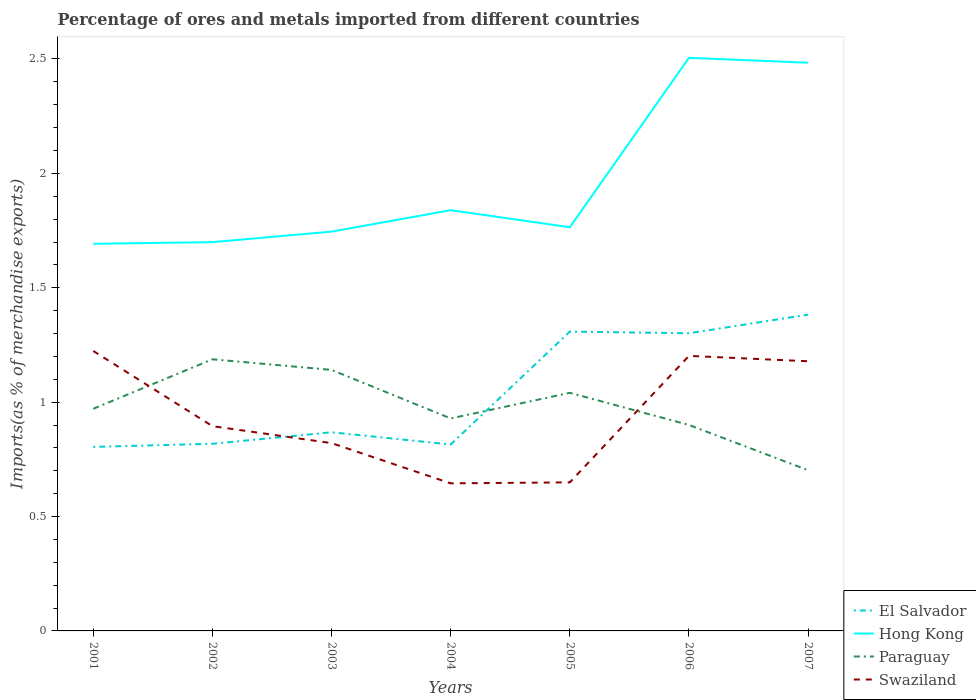How many different coloured lines are there?
Keep it short and to the point. 4. Does the line corresponding to Swaziland intersect with the line corresponding to Paraguay?
Keep it short and to the point. Yes. Across all years, what is the maximum percentage of imports to different countries in Swaziland?
Your answer should be compact. 0.65. In which year was the percentage of imports to different countries in Paraguay maximum?
Give a very brief answer. 2007. What is the total percentage of imports to different countries in Swaziland in the graph?
Provide a short and direct response. -0.53. What is the difference between the highest and the second highest percentage of imports to different countries in Swaziland?
Your response must be concise. 0.58. What is the difference between the highest and the lowest percentage of imports to different countries in Hong Kong?
Offer a very short reply. 2. How many lines are there?
Offer a very short reply. 4. Are the values on the major ticks of Y-axis written in scientific E-notation?
Your answer should be very brief. No. Does the graph contain any zero values?
Keep it short and to the point. No. Does the graph contain grids?
Your answer should be compact. No. Where does the legend appear in the graph?
Provide a short and direct response. Bottom right. What is the title of the graph?
Provide a succinct answer. Percentage of ores and metals imported from different countries. What is the label or title of the Y-axis?
Your response must be concise. Imports(as % of merchandise exports). What is the Imports(as % of merchandise exports) in El Salvador in 2001?
Offer a terse response. 0.8. What is the Imports(as % of merchandise exports) of Hong Kong in 2001?
Make the answer very short. 1.69. What is the Imports(as % of merchandise exports) of Paraguay in 2001?
Provide a succinct answer. 0.97. What is the Imports(as % of merchandise exports) in Swaziland in 2001?
Your answer should be compact. 1.22. What is the Imports(as % of merchandise exports) in El Salvador in 2002?
Give a very brief answer. 0.82. What is the Imports(as % of merchandise exports) of Hong Kong in 2002?
Give a very brief answer. 1.7. What is the Imports(as % of merchandise exports) in Paraguay in 2002?
Provide a succinct answer. 1.19. What is the Imports(as % of merchandise exports) of Swaziland in 2002?
Offer a very short reply. 0.9. What is the Imports(as % of merchandise exports) of El Salvador in 2003?
Ensure brevity in your answer.  0.87. What is the Imports(as % of merchandise exports) in Hong Kong in 2003?
Offer a very short reply. 1.75. What is the Imports(as % of merchandise exports) of Paraguay in 2003?
Ensure brevity in your answer.  1.14. What is the Imports(as % of merchandise exports) in Swaziland in 2003?
Offer a very short reply. 0.82. What is the Imports(as % of merchandise exports) in El Salvador in 2004?
Keep it short and to the point. 0.81. What is the Imports(as % of merchandise exports) in Hong Kong in 2004?
Your answer should be compact. 1.84. What is the Imports(as % of merchandise exports) of Paraguay in 2004?
Provide a succinct answer. 0.93. What is the Imports(as % of merchandise exports) of Swaziland in 2004?
Keep it short and to the point. 0.65. What is the Imports(as % of merchandise exports) of El Salvador in 2005?
Make the answer very short. 1.31. What is the Imports(as % of merchandise exports) of Hong Kong in 2005?
Offer a very short reply. 1.76. What is the Imports(as % of merchandise exports) of Paraguay in 2005?
Your answer should be very brief. 1.04. What is the Imports(as % of merchandise exports) of Swaziland in 2005?
Your answer should be very brief. 0.65. What is the Imports(as % of merchandise exports) in El Salvador in 2006?
Give a very brief answer. 1.3. What is the Imports(as % of merchandise exports) in Hong Kong in 2006?
Offer a very short reply. 2.5. What is the Imports(as % of merchandise exports) of Paraguay in 2006?
Keep it short and to the point. 0.9. What is the Imports(as % of merchandise exports) in Swaziland in 2006?
Give a very brief answer. 1.2. What is the Imports(as % of merchandise exports) in El Salvador in 2007?
Offer a terse response. 1.38. What is the Imports(as % of merchandise exports) in Hong Kong in 2007?
Make the answer very short. 2.48. What is the Imports(as % of merchandise exports) of Paraguay in 2007?
Give a very brief answer. 0.7. What is the Imports(as % of merchandise exports) in Swaziland in 2007?
Your response must be concise. 1.18. Across all years, what is the maximum Imports(as % of merchandise exports) in El Salvador?
Make the answer very short. 1.38. Across all years, what is the maximum Imports(as % of merchandise exports) of Hong Kong?
Make the answer very short. 2.5. Across all years, what is the maximum Imports(as % of merchandise exports) in Paraguay?
Offer a terse response. 1.19. Across all years, what is the maximum Imports(as % of merchandise exports) of Swaziland?
Keep it short and to the point. 1.22. Across all years, what is the minimum Imports(as % of merchandise exports) in El Salvador?
Offer a very short reply. 0.8. Across all years, what is the minimum Imports(as % of merchandise exports) in Hong Kong?
Your response must be concise. 1.69. Across all years, what is the minimum Imports(as % of merchandise exports) in Paraguay?
Make the answer very short. 0.7. Across all years, what is the minimum Imports(as % of merchandise exports) of Swaziland?
Offer a terse response. 0.65. What is the total Imports(as % of merchandise exports) of El Salvador in the graph?
Provide a succinct answer. 7.3. What is the total Imports(as % of merchandise exports) of Hong Kong in the graph?
Your answer should be compact. 13.73. What is the total Imports(as % of merchandise exports) in Paraguay in the graph?
Your response must be concise. 6.87. What is the total Imports(as % of merchandise exports) of Swaziland in the graph?
Your answer should be very brief. 6.62. What is the difference between the Imports(as % of merchandise exports) in El Salvador in 2001 and that in 2002?
Provide a succinct answer. -0.01. What is the difference between the Imports(as % of merchandise exports) in Hong Kong in 2001 and that in 2002?
Your answer should be compact. -0.01. What is the difference between the Imports(as % of merchandise exports) of Paraguay in 2001 and that in 2002?
Offer a very short reply. -0.22. What is the difference between the Imports(as % of merchandise exports) in Swaziland in 2001 and that in 2002?
Your response must be concise. 0.33. What is the difference between the Imports(as % of merchandise exports) of El Salvador in 2001 and that in 2003?
Give a very brief answer. -0.06. What is the difference between the Imports(as % of merchandise exports) in Hong Kong in 2001 and that in 2003?
Offer a very short reply. -0.05. What is the difference between the Imports(as % of merchandise exports) in Paraguay in 2001 and that in 2003?
Your answer should be compact. -0.17. What is the difference between the Imports(as % of merchandise exports) in Swaziland in 2001 and that in 2003?
Your answer should be compact. 0.4. What is the difference between the Imports(as % of merchandise exports) of El Salvador in 2001 and that in 2004?
Make the answer very short. -0.01. What is the difference between the Imports(as % of merchandise exports) of Hong Kong in 2001 and that in 2004?
Offer a terse response. -0.15. What is the difference between the Imports(as % of merchandise exports) of Paraguay in 2001 and that in 2004?
Your response must be concise. 0.04. What is the difference between the Imports(as % of merchandise exports) of Swaziland in 2001 and that in 2004?
Offer a very short reply. 0.58. What is the difference between the Imports(as % of merchandise exports) in El Salvador in 2001 and that in 2005?
Ensure brevity in your answer.  -0.5. What is the difference between the Imports(as % of merchandise exports) in Hong Kong in 2001 and that in 2005?
Ensure brevity in your answer.  -0.07. What is the difference between the Imports(as % of merchandise exports) of Paraguay in 2001 and that in 2005?
Your answer should be compact. -0.07. What is the difference between the Imports(as % of merchandise exports) in Swaziland in 2001 and that in 2005?
Your response must be concise. 0.57. What is the difference between the Imports(as % of merchandise exports) in El Salvador in 2001 and that in 2006?
Your answer should be very brief. -0.5. What is the difference between the Imports(as % of merchandise exports) of Hong Kong in 2001 and that in 2006?
Give a very brief answer. -0.81. What is the difference between the Imports(as % of merchandise exports) of Paraguay in 2001 and that in 2006?
Your answer should be very brief. 0.07. What is the difference between the Imports(as % of merchandise exports) of Swaziland in 2001 and that in 2006?
Offer a terse response. 0.02. What is the difference between the Imports(as % of merchandise exports) of El Salvador in 2001 and that in 2007?
Make the answer very short. -0.58. What is the difference between the Imports(as % of merchandise exports) in Hong Kong in 2001 and that in 2007?
Your answer should be compact. -0.79. What is the difference between the Imports(as % of merchandise exports) in Paraguay in 2001 and that in 2007?
Your response must be concise. 0.27. What is the difference between the Imports(as % of merchandise exports) in Swaziland in 2001 and that in 2007?
Give a very brief answer. 0.04. What is the difference between the Imports(as % of merchandise exports) of El Salvador in 2002 and that in 2003?
Make the answer very short. -0.05. What is the difference between the Imports(as % of merchandise exports) in Hong Kong in 2002 and that in 2003?
Offer a very short reply. -0.05. What is the difference between the Imports(as % of merchandise exports) of Paraguay in 2002 and that in 2003?
Your response must be concise. 0.05. What is the difference between the Imports(as % of merchandise exports) of Swaziland in 2002 and that in 2003?
Make the answer very short. 0.07. What is the difference between the Imports(as % of merchandise exports) of El Salvador in 2002 and that in 2004?
Ensure brevity in your answer.  0. What is the difference between the Imports(as % of merchandise exports) of Hong Kong in 2002 and that in 2004?
Make the answer very short. -0.14. What is the difference between the Imports(as % of merchandise exports) in Paraguay in 2002 and that in 2004?
Make the answer very short. 0.26. What is the difference between the Imports(as % of merchandise exports) of El Salvador in 2002 and that in 2005?
Keep it short and to the point. -0.49. What is the difference between the Imports(as % of merchandise exports) in Hong Kong in 2002 and that in 2005?
Offer a very short reply. -0.07. What is the difference between the Imports(as % of merchandise exports) in Paraguay in 2002 and that in 2005?
Your answer should be very brief. 0.15. What is the difference between the Imports(as % of merchandise exports) of Swaziland in 2002 and that in 2005?
Provide a short and direct response. 0.25. What is the difference between the Imports(as % of merchandise exports) in El Salvador in 2002 and that in 2006?
Offer a terse response. -0.48. What is the difference between the Imports(as % of merchandise exports) of Hong Kong in 2002 and that in 2006?
Give a very brief answer. -0.81. What is the difference between the Imports(as % of merchandise exports) of Paraguay in 2002 and that in 2006?
Keep it short and to the point. 0.29. What is the difference between the Imports(as % of merchandise exports) of Swaziland in 2002 and that in 2006?
Offer a very short reply. -0.31. What is the difference between the Imports(as % of merchandise exports) of El Salvador in 2002 and that in 2007?
Offer a terse response. -0.56. What is the difference between the Imports(as % of merchandise exports) of Hong Kong in 2002 and that in 2007?
Offer a very short reply. -0.78. What is the difference between the Imports(as % of merchandise exports) in Paraguay in 2002 and that in 2007?
Your answer should be compact. 0.48. What is the difference between the Imports(as % of merchandise exports) of Swaziland in 2002 and that in 2007?
Offer a very short reply. -0.28. What is the difference between the Imports(as % of merchandise exports) in El Salvador in 2003 and that in 2004?
Provide a succinct answer. 0.05. What is the difference between the Imports(as % of merchandise exports) in Hong Kong in 2003 and that in 2004?
Keep it short and to the point. -0.09. What is the difference between the Imports(as % of merchandise exports) in Paraguay in 2003 and that in 2004?
Give a very brief answer. 0.21. What is the difference between the Imports(as % of merchandise exports) in Swaziland in 2003 and that in 2004?
Keep it short and to the point. 0.18. What is the difference between the Imports(as % of merchandise exports) in El Salvador in 2003 and that in 2005?
Make the answer very short. -0.44. What is the difference between the Imports(as % of merchandise exports) in Hong Kong in 2003 and that in 2005?
Offer a terse response. -0.02. What is the difference between the Imports(as % of merchandise exports) in Paraguay in 2003 and that in 2005?
Offer a terse response. 0.1. What is the difference between the Imports(as % of merchandise exports) of Swaziland in 2003 and that in 2005?
Provide a succinct answer. 0.17. What is the difference between the Imports(as % of merchandise exports) of El Salvador in 2003 and that in 2006?
Offer a terse response. -0.43. What is the difference between the Imports(as % of merchandise exports) in Hong Kong in 2003 and that in 2006?
Give a very brief answer. -0.76. What is the difference between the Imports(as % of merchandise exports) in Paraguay in 2003 and that in 2006?
Your answer should be compact. 0.24. What is the difference between the Imports(as % of merchandise exports) in Swaziland in 2003 and that in 2006?
Ensure brevity in your answer.  -0.38. What is the difference between the Imports(as % of merchandise exports) of El Salvador in 2003 and that in 2007?
Ensure brevity in your answer.  -0.51. What is the difference between the Imports(as % of merchandise exports) in Hong Kong in 2003 and that in 2007?
Your answer should be very brief. -0.74. What is the difference between the Imports(as % of merchandise exports) of Paraguay in 2003 and that in 2007?
Your response must be concise. 0.44. What is the difference between the Imports(as % of merchandise exports) of Swaziland in 2003 and that in 2007?
Give a very brief answer. -0.36. What is the difference between the Imports(as % of merchandise exports) in El Salvador in 2004 and that in 2005?
Ensure brevity in your answer.  -0.49. What is the difference between the Imports(as % of merchandise exports) of Hong Kong in 2004 and that in 2005?
Make the answer very short. 0.07. What is the difference between the Imports(as % of merchandise exports) in Paraguay in 2004 and that in 2005?
Give a very brief answer. -0.11. What is the difference between the Imports(as % of merchandise exports) of Swaziland in 2004 and that in 2005?
Your answer should be very brief. -0. What is the difference between the Imports(as % of merchandise exports) of El Salvador in 2004 and that in 2006?
Provide a short and direct response. -0.49. What is the difference between the Imports(as % of merchandise exports) in Hong Kong in 2004 and that in 2006?
Provide a succinct answer. -0.67. What is the difference between the Imports(as % of merchandise exports) in Paraguay in 2004 and that in 2006?
Offer a terse response. 0.03. What is the difference between the Imports(as % of merchandise exports) in Swaziland in 2004 and that in 2006?
Your answer should be very brief. -0.56. What is the difference between the Imports(as % of merchandise exports) in El Salvador in 2004 and that in 2007?
Ensure brevity in your answer.  -0.57. What is the difference between the Imports(as % of merchandise exports) of Hong Kong in 2004 and that in 2007?
Offer a terse response. -0.64. What is the difference between the Imports(as % of merchandise exports) of Paraguay in 2004 and that in 2007?
Your answer should be compact. 0.23. What is the difference between the Imports(as % of merchandise exports) of Swaziland in 2004 and that in 2007?
Give a very brief answer. -0.53. What is the difference between the Imports(as % of merchandise exports) in El Salvador in 2005 and that in 2006?
Keep it short and to the point. 0.01. What is the difference between the Imports(as % of merchandise exports) of Hong Kong in 2005 and that in 2006?
Your answer should be very brief. -0.74. What is the difference between the Imports(as % of merchandise exports) of Paraguay in 2005 and that in 2006?
Offer a terse response. 0.14. What is the difference between the Imports(as % of merchandise exports) of Swaziland in 2005 and that in 2006?
Offer a very short reply. -0.55. What is the difference between the Imports(as % of merchandise exports) in El Salvador in 2005 and that in 2007?
Provide a succinct answer. -0.07. What is the difference between the Imports(as % of merchandise exports) in Hong Kong in 2005 and that in 2007?
Make the answer very short. -0.72. What is the difference between the Imports(as % of merchandise exports) of Paraguay in 2005 and that in 2007?
Your response must be concise. 0.34. What is the difference between the Imports(as % of merchandise exports) of Swaziland in 2005 and that in 2007?
Provide a succinct answer. -0.53. What is the difference between the Imports(as % of merchandise exports) in El Salvador in 2006 and that in 2007?
Make the answer very short. -0.08. What is the difference between the Imports(as % of merchandise exports) in Hong Kong in 2006 and that in 2007?
Offer a terse response. 0.02. What is the difference between the Imports(as % of merchandise exports) of Paraguay in 2006 and that in 2007?
Offer a very short reply. 0.2. What is the difference between the Imports(as % of merchandise exports) of Swaziland in 2006 and that in 2007?
Provide a short and direct response. 0.02. What is the difference between the Imports(as % of merchandise exports) of El Salvador in 2001 and the Imports(as % of merchandise exports) of Hong Kong in 2002?
Offer a very short reply. -0.9. What is the difference between the Imports(as % of merchandise exports) of El Salvador in 2001 and the Imports(as % of merchandise exports) of Paraguay in 2002?
Provide a succinct answer. -0.38. What is the difference between the Imports(as % of merchandise exports) in El Salvador in 2001 and the Imports(as % of merchandise exports) in Swaziland in 2002?
Your response must be concise. -0.09. What is the difference between the Imports(as % of merchandise exports) of Hong Kong in 2001 and the Imports(as % of merchandise exports) of Paraguay in 2002?
Offer a terse response. 0.5. What is the difference between the Imports(as % of merchandise exports) in Hong Kong in 2001 and the Imports(as % of merchandise exports) in Swaziland in 2002?
Ensure brevity in your answer.  0.8. What is the difference between the Imports(as % of merchandise exports) in Paraguay in 2001 and the Imports(as % of merchandise exports) in Swaziland in 2002?
Your answer should be very brief. 0.08. What is the difference between the Imports(as % of merchandise exports) of El Salvador in 2001 and the Imports(as % of merchandise exports) of Hong Kong in 2003?
Make the answer very short. -0.94. What is the difference between the Imports(as % of merchandise exports) in El Salvador in 2001 and the Imports(as % of merchandise exports) in Paraguay in 2003?
Provide a short and direct response. -0.34. What is the difference between the Imports(as % of merchandise exports) of El Salvador in 2001 and the Imports(as % of merchandise exports) of Swaziland in 2003?
Offer a very short reply. -0.02. What is the difference between the Imports(as % of merchandise exports) in Hong Kong in 2001 and the Imports(as % of merchandise exports) in Paraguay in 2003?
Keep it short and to the point. 0.55. What is the difference between the Imports(as % of merchandise exports) of Hong Kong in 2001 and the Imports(as % of merchandise exports) of Swaziland in 2003?
Offer a very short reply. 0.87. What is the difference between the Imports(as % of merchandise exports) of Paraguay in 2001 and the Imports(as % of merchandise exports) of Swaziland in 2003?
Make the answer very short. 0.15. What is the difference between the Imports(as % of merchandise exports) of El Salvador in 2001 and the Imports(as % of merchandise exports) of Hong Kong in 2004?
Your answer should be very brief. -1.03. What is the difference between the Imports(as % of merchandise exports) in El Salvador in 2001 and the Imports(as % of merchandise exports) in Paraguay in 2004?
Make the answer very short. -0.12. What is the difference between the Imports(as % of merchandise exports) of El Salvador in 2001 and the Imports(as % of merchandise exports) of Swaziland in 2004?
Give a very brief answer. 0.16. What is the difference between the Imports(as % of merchandise exports) in Hong Kong in 2001 and the Imports(as % of merchandise exports) in Paraguay in 2004?
Your answer should be compact. 0.76. What is the difference between the Imports(as % of merchandise exports) of Hong Kong in 2001 and the Imports(as % of merchandise exports) of Swaziland in 2004?
Your answer should be compact. 1.05. What is the difference between the Imports(as % of merchandise exports) in Paraguay in 2001 and the Imports(as % of merchandise exports) in Swaziland in 2004?
Provide a short and direct response. 0.33. What is the difference between the Imports(as % of merchandise exports) of El Salvador in 2001 and the Imports(as % of merchandise exports) of Hong Kong in 2005?
Provide a short and direct response. -0.96. What is the difference between the Imports(as % of merchandise exports) in El Salvador in 2001 and the Imports(as % of merchandise exports) in Paraguay in 2005?
Your response must be concise. -0.24. What is the difference between the Imports(as % of merchandise exports) of El Salvador in 2001 and the Imports(as % of merchandise exports) of Swaziland in 2005?
Keep it short and to the point. 0.15. What is the difference between the Imports(as % of merchandise exports) of Hong Kong in 2001 and the Imports(as % of merchandise exports) of Paraguay in 2005?
Keep it short and to the point. 0.65. What is the difference between the Imports(as % of merchandise exports) in Hong Kong in 2001 and the Imports(as % of merchandise exports) in Swaziland in 2005?
Make the answer very short. 1.04. What is the difference between the Imports(as % of merchandise exports) of Paraguay in 2001 and the Imports(as % of merchandise exports) of Swaziland in 2005?
Ensure brevity in your answer.  0.32. What is the difference between the Imports(as % of merchandise exports) of El Salvador in 2001 and the Imports(as % of merchandise exports) of Hong Kong in 2006?
Your response must be concise. -1.7. What is the difference between the Imports(as % of merchandise exports) in El Salvador in 2001 and the Imports(as % of merchandise exports) in Paraguay in 2006?
Provide a succinct answer. -0.1. What is the difference between the Imports(as % of merchandise exports) of El Salvador in 2001 and the Imports(as % of merchandise exports) of Swaziland in 2006?
Your answer should be compact. -0.4. What is the difference between the Imports(as % of merchandise exports) of Hong Kong in 2001 and the Imports(as % of merchandise exports) of Paraguay in 2006?
Keep it short and to the point. 0.79. What is the difference between the Imports(as % of merchandise exports) in Hong Kong in 2001 and the Imports(as % of merchandise exports) in Swaziland in 2006?
Offer a very short reply. 0.49. What is the difference between the Imports(as % of merchandise exports) in Paraguay in 2001 and the Imports(as % of merchandise exports) in Swaziland in 2006?
Provide a succinct answer. -0.23. What is the difference between the Imports(as % of merchandise exports) in El Salvador in 2001 and the Imports(as % of merchandise exports) in Hong Kong in 2007?
Provide a short and direct response. -1.68. What is the difference between the Imports(as % of merchandise exports) in El Salvador in 2001 and the Imports(as % of merchandise exports) in Paraguay in 2007?
Provide a short and direct response. 0.1. What is the difference between the Imports(as % of merchandise exports) in El Salvador in 2001 and the Imports(as % of merchandise exports) in Swaziland in 2007?
Provide a succinct answer. -0.37. What is the difference between the Imports(as % of merchandise exports) in Hong Kong in 2001 and the Imports(as % of merchandise exports) in Paraguay in 2007?
Offer a terse response. 0.99. What is the difference between the Imports(as % of merchandise exports) in Hong Kong in 2001 and the Imports(as % of merchandise exports) in Swaziland in 2007?
Keep it short and to the point. 0.51. What is the difference between the Imports(as % of merchandise exports) in Paraguay in 2001 and the Imports(as % of merchandise exports) in Swaziland in 2007?
Provide a succinct answer. -0.21. What is the difference between the Imports(as % of merchandise exports) in El Salvador in 2002 and the Imports(as % of merchandise exports) in Hong Kong in 2003?
Give a very brief answer. -0.93. What is the difference between the Imports(as % of merchandise exports) of El Salvador in 2002 and the Imports(as % of merchandise exports) of Paraguay in 2003?
Your answer should be very brief. -0.32. What is the difference between the Imports(as % of merchandise exports) of El Salvador in 2002 and the Imports(as % of merchandise exports) of Swaziland in 2003?
Ensure brevity in your answer.  -0. What is the difference between the Imports(as % of merchandise exports) in Hong Kong in 2002 and the Imports(as % of merchandise exports) in Paraguay in 2003?
Offer a very short reply. 0.56. What is the difference between the Imports(as % of merchandise exports) of Hong Kong in 2002 and the Imports(as % of merchandise exports) of Swaziland in 2003?
Keep it short and to the point. 0.88. What is the difference between the Imports(as % of merchandise exports) of Paraguay in 2002 and the Imports(as % of merchandise exports) of Swaziland in 2003?
Ensure brevity in your answer.  0.37. What is the difference between the Imports(as % of merchandise exports) in El Salvador in 2002 and the Imports(as % of merchandise exports) in Hong Kong in 2004?
Give a very brief answer. -1.02. What is the difference between the Imports(as % of merchandise exports) of El Salvador in 2002 and the Imports(as % of merchandise exports) of Paraguay in 2004?
Your answer should be very brief. -0.11. What is the difference between the Imports(as % of merchandise exports) of El Salvador in 2002 and the Imports(as % of merchandise exports) of Swaziland in 2004?
Provide a succinct answer. 0.17. What is the difference between the Imports(as % of merchandise exports) of Hong Kong in 2002 and the Imports(as % of merchandise exports) of Paraguay in 2004?
Your answer should be compact. 0.77. What is the difference between the Imports(as % of merchandise exports) of Hong Kong in 2002 and the Imports(as % of merchandise exports) of Swaziland in 2004?
Give a very brief answer. 1.05. What is the difference between the Imports(as % of merchandise exports) in Paraguay in 2002 and the Imports(as % of merchandise exports) in Swaziland in 2004?
Your answer should be very brief. 0.54. What is the difference between the Imports(as % of merchandise exports) of El Salvador in 2002 and the Imports(as % of merchandise exports) of Hong Kong in 2005?
Provide a short and direct response. -0.95. What is the difference between the Imports(as % of merchandise exports) of El Salvador in 2002 and the Imports(as % of merchandise exports) of Paraguay in 2005?
Provide a short and direct response. -0.22. What is the difference between the Imports(as % of merchandise exports) of El Salvador in 2002 and the Imports(as % of merchandise exports) of Swaziland in 2005?
Provide a short and direct response. 0.17. What is the difference between the Imports(as % of merchandise exports) in Hong Kong in 2002 and the Imports(as % of merchandise exports) in Paraguay in 2005?
Your answer should be compact. 0.66. What is the difference between the Imports(as % of merchandise exports) of Hong Kong in 2002 and the Imports(as % of merchandise exports) of Swaziland in 2005?
Keep it short and to the point. 1.05. What is the difference between the Imports(as % of merchandise exports) in Paraguay in 2002 and the Imports(as % of merchandise exports) in Swaziland in 2005?
Ensure brevity in your answer.  0.54. What is the difference between the Imports(as % of merchandise exports) of El Salvador in 2002 and the Imports(as % of merchandise exports) of Hong Kong in 2006?
Keep it short and to the point. -1.69. What is the difference between the Imports(as % of merchandise exports) in El Salvador in 2002 and the Imports(as % of merchandise exports) in Paraguay in 2006?
Give a very brief answer. -0.08. What is the difference between the Imports(as % of merchandise exports) of El Salvador in 2002 and the Imports(as % of merchandise exports) of Swaziland in 2006?
Your response must be concise. -0.38. What is the difference between the Imports(as % of merchandise exports) in Hong Kong in 2002 and the Imports(as % of merchandise exports) in Paraguay in 2006?
Offer a very short reply. 0.8. What is the difference between the Imports(as % of merchandise exports) in Hong Kong in 2002 and the Imports(as % of merchandise exports) in Swaziland in 2006?
Your answer should be compact. 0.5. What is the difference between the Imports(as % of merchandise exports) of Paraguay in 2002 and the Imports(as % of merchandise exports) of Swaziland in 2006?
Offer a terse response. -0.01. What is the difference between the Imports(as % of merchandise exports) in El Salvador in 2002 and the Imports(as % of merchandise exports) in Hong Kong in 2007?
Ensure brevity in your answer.  -1.67. What is the difference between the Imports(as % of merchandise exports) of El Salvador in 2002 and the Imports(as % of merchandise exports) of Paraguay in 2007?
Keep it short and to the point. 0.12. What is the difference between the Imports(as % of merchandise exports) of El Salvador in 2002 and the Imports(as % of merchandise exports) of Swaziland in 2007?
Your answer should be very brief. -0.36. What is the difference between the Imports(as % of merchandise exports) in Hong Kong in 2002 and the Imports(as % of merchandise exports) in Swaziland in 2007?
Provide a short and direct response. 0.52. What is the difference between the Imports(as % of merchandise exports) of Paraguay in 2002 and the Imports(as % of merchandise exports) of Swaziland in 2007?
Give a very brief answer. 0.01. What is the difference between the Imports(as % of merchandise exports) in El Salvador in 2003 and the Imports(as % of merchandise exports) in Hong Kong in 2004?
Your answer should be very brief. -0.97. What is the difference between the Imports(as % of merchandise exports) of El Salvador in 2003 and the Imports(as % of merchandise exports) of Paraguay in 2004?
Offer a terse response. -0.06. What is the difference between the Imports(as % of merchandise exports) of El Salvador in 2003 and the Imports(as % of merchandise exports) of Swaziland in 2004?
Give a very brief answer. 0.22. What is the difference between the Imports(as % of merchandise exports) of Hong Kong in 2003 and the Imports(as % of merchandise exports) of Paraguay in 2004?
Provide a succinct answer. 0.82. What is the difference between the Imports(as % of merchandise exports) in Hong Kong in 2003 and the Imports(as % of merchandise exports) in Swaziland in 2004?
Your response must be concise. 1.1. What is the difference between the Imports(as % of merchandise exports) of Paraguay in 2003 and the Imports(as % of merchandise exports) of Swaziland in 2004?
Ensure brevity in your answer.  0.5. What is the difference between the Imports(as % of merchandise exports) of El Salvador in 2003 and the Imports(as % of merchandise exports) of Hong Kong in 2005?
Provide a succinct answer. -0.9. What is the difference between the Imports(as % of merchandise exports) in El Salvador in 2003 and the Imports(as % of merchandise exports) in Paraguay in 2005?
Your answer should be compact. -0.17. What is the difference between the Imports(as % of merchandise exports) in El Salvador in 2003 and the Imports(as % of merchandise exports) in Swaziland in 2005?
Offer a terse response. 0.22. What is the difference between the Imports(as % of merchandise exports) in Hong Kong in 2003 and the Imports(as % of merchandise exports) in Paraguay in 2005?
Your answer should be compact. 0.7. What is the difference between the Imports(as % of merchandise exports) in Hong Kong in 2003 and the Imports(as % of merchandise exports) in Swaziland in 2005?
Keep it short and to the point. 1.1. What is the difference between the Imports(as % of merchandise exports) of Paraguay in 2003 and the Imports(as % of merchandise exports) of Swaziland in 2005?
Give a very brief answer. 0.49. What is the difference between the Imports(as % of merchandise exports) of El Salvador in 2003 and the Imports(as % of merchandise exports) of Hong Kong in 2006?
Offer a very short reply. -1.64. What is the difference between the Imports(as % of merchandise exports) in El Salvador in 2003 and the Imports(as % of merchandise exports) in Paraguay in 2006?
Your response must be concise. -0.03. What is the difference between the Imports(as % of merchandise exports) in El Salvador in 2003 and the Imports(as % of merchandise exports) in Swaziland in 2006?
Ensure brevity in your answer.  -0.33. What is the difference between the Imports(as % of merchandise exports) in Hong Kong in 2003 and the Imports(as % of merchandise exports) in Paraguay in 2006?
Provide a short and direct response. 0.85. What is the difference between the Imports(as % of merchandise exports) in Hong Kong in 2003 and the Imports(as % of merchandise exports) in Swaziland in 2006?
Provide a short and direct response. 0.54. What is the difference between the Imports(as % of merchandise exports) of Paraguay in 2003 and the Imports(as % of merchandise exports) of Swaziland in 2006?
Offer a very short reply. -0.06. What is the difference between the Imports(as % of merchandise exports) in El Salvador in 2003 and the Imports(as % of merchandise exports) in Hong Kong in 2007?
Give a very brief answer. -1.62. What is the difference between the Imports(as % of merchandise exports) in El Salvador in 2003 and the Imports(as % of merchandise exports) in Paraguay in 2007?
Provide a succinct answer. 0.17. What is the difference between the Imports(as % of merchandise exports) in El Salvador in 2003 and the Imports(as % of merchandise exports) in Swaziland in 2007?
Your answer should be compact. -0.31. What is the difference between the Imports(as % of merchandise exports) of Hong Kong in 2003 and the Imports(as % of merchandise exports) of Paraguay in 2007?
Your answer should be compact. 1.04. What is the difference between the Imports(as % of merchandise exports) in Hong Kong in 2003 and the Imports(as % of merchandise exports) in Swaziland in 2007?
Make the answer very short. 0.57. What is the difference between the Imports(as % of merchandise exports) in Paraguay in 2003 and the Imports(as % of merchandise exports) in Swaziland in 2007?
Keep it short and to the point. -0.04. What is the difference between the Imports(as % of merchandise exports) in El Salvador in 2004 and the Imports(as % of merchandise exports) in Hong Kong in 2005?
Your response must be concise. -0.95. What is the difference between the Imports(as % of merchandise exports) of El Salvador in 2004 and the Imports(as % of merchandise exports) of Paraguay in 2005?
Provide a succinct answer. -0.23. What is the difference between the Imports(as % of merchandise exports) of El Salvador in 2004 and the Imports(as % of merchandise exports) of Swaziland in 2005?
Make the answer very short. 0.17. What is the difference between the Imports(as % of merchandise exports) of Hong Kong in 2004 and the Imports(as % of merchandise exports) of Paraguay in 2005?
Keep it short and to the point. 0.8. What is the difference between the Imports(as % of merchandise exports) of Hong Kong in 2004 and the Imports(as % of merchandise exports) of Swaziland in 2005?
Make the answer very short. 1.19. What is the difference between the Imports(as % of merchandise exports) in Paraguay in 2004 and the Imports(as % of merchandise exports) in Swaziland in 2005?
Give a very brief answer. 0.28. What is the difference between the Imports(as % of merchandise exports) of El Salvador in 2004 and the Imports(as % of merchandise exports) of Hong Kong in 2006?
Keep it short and to the point. -1.69. What is the difference between the Imports(as % of merchandise exports) of El Salvador in 2004 and the Imports(as % of merchandise exports) of Paraguay in 2006?
Offer a terse response. -0.09. What is the difference between the Imports(as % of merchandise exports) in El Salvador in 2004 and the Imports(as % of merchandise exports) in Swaziland in 2006?
Keep it short and to the point. -0.39. What is the difference between the Imports(as % of merchandise exports) in Hong Kong in 2004 and the Imports(as % of merchandise exports) in Paraguay in 2006?
Your answer should be very brief. 0.94. What is the difference between the Imports(as % of merchandise exports) of Hong Kong in 2004 and the Imports(as % of merchandise exports) of Swaziland in 2006?
Give a very brief answer. 0.64. What is the difference between the Imports(as % of merchandise exports) in Paraguay in 2004 and the Imports(as % of merchandise exports) in Swaziland in 2006?
Make the answer very short. -0.27. What is the difference between the Imports(as % of merchandise exports) in El Salvador in 2004 and the Imports(as % of merchandise exports) in Hong Kong in 2007?
Provide a short and direct response. -1.67. What is the difference between the Imports(as % of merchandise exports) of El Salvador in 2004 and the Imports(as % of merchandise exports) of Paraguay in 2007?
Offer a very short reply. 0.11. What is the difference between the Imports(as % of merchandise exports) of El Salvador in 2004 and the Imports(as % of merchandise exports) of Swaziland in 2007?
Make the answer very short. -0.36. What is the difference between the Imports(as % of merchandise exports) in Hong Kong in 2004 and the Imports(as % of merchandise exports) in Paraguay in 2007?
Your answer should be very brief. 1.14. What is the difference between the Imports(as % of merchandise exports) in Hong Kong in 2004 and the Imports(as % of merchandise exports) in Swaziland in 2007?
Provide a short and direct response. 0.66. What is the difference between the Imports(as % of merchandise exports) in Paraguay in 2004 and the Imports(as % of merchandise exports) in Swaziland in 2007?
Provide a short and direct response. -0.25. What is the difference between the Imports(as % of merchandise exports) in El Salvador in 2005 and the Imports(as % of merchandise exports) in Hong Kong in 2006?
Offer a very short reply. -1.2. What is the difference between the Imports(as % of merchandise exports) of El Salvador in 2005 and the Imports(as % of merchandise exports) of Paraguay in 2006?
Make the answer very short. 0.41. What is the difference between the Imports(as % of merchandise exports) of El Salvador in 2005 and the Imports(as % of merchandise exports) of Swaziland in 2006?
Offer a very short reply. 0.11. What is the difference between the Imports(as % of merchandise exports) of Hong Kong in 2005 and the Imports(as % of merchandise exports) of Paraguay in 2006?
Offer a terse response. 0.86. What is the difference between the Imports(as % of merchandise exports) in Hong Kong in 2005 and the Imports(as % of merchandise exports) in Swaziland in 2006?
Keep it short and to the point. 0.56. What is the difference between the Imports(as % of merchandise exports) in Paraguay in 2005 and the Imports(as % of merchandise exports) in Swaziland in 2006?
Offer a terse response. -0.16. What is the difference between the Imports(as % of merchandise exports) of El Salvador in 2005 and the Imports(as % of merchandise exports) of Hong Kong in 2007?
Give a very brief answer. -1.18. What is the difference between the Imports(as % of merchandise exports) of El Salvador in 2005 and the Imports(as % of merchandise exports) of Paraguay in 2007?
Offer a terse response. 0.61. What is the difference between the Imports(as % of merchandise exports) in El Salvador in 2005 and the Imports(as % of merchandise exports) in Swaziland in 2007?
Provide a short and direct response. 0.13. What is the difference between the Imports(as % of merchandise exports) in Hong Kong in 2005 and the Imports(as % of merchandise exports) in Paraguay in 2007?
Offer a very short reply. 1.06. What is the difference between the Imports(as % of merchandise exports) in Hong Kong in 2005 and the Imports(as % of merchandise exports) in Swaziland in 2007?
Keep it short and to the point. 0.59. What is the difference between the Imports(as % of merchandise exports) of Paraguay in 2005 and the Imports(as % of merchandise exports) of Swaziland in 2007?
Provide a succinct answer. -0.14. What is the difference between the Imports(as % of merchandise exports) of El Salvador in 2006 and the Imports(as % of merchandise exports) of Hong Kong in 2007?
Keep it short and to the point. -1.18. What is the difference between the Imports(as % of merchandise exports) in El Salvador in 2006 and the Imports(as % of merchandise exports) in Paraguay in 2007?
Give a very brief answer. 0.6. What is the difference between the Imports(as % of merchandise exports) in El Salvador in 2006 and the Imports(as % of merchandise exports) in Swaziland in 2007?
Your response must be concise. 0.12. What is the difference between the Imports(as % of merchandise exports) of Hong Kong in 2006 and the Imports(as % of merchandise exports) of Paraguay in 2007?
Give a very brief answer. 1.8. What is the difference between the Imports(as % of merchandise exports) in Hong Kong in 2006 and the Imports(as % of merchandise exports) in Swaziland in 2007?
Ensure brevity in your answer.  1.33. What is the difference between the Imports(as % of merchandise exports) in Paraguay in 2006 and the Imports(as % of merchandise exports) in Swaziland in 2007?
Ensure brevity in your answer.  -0.28. What is the average Imports(as % of merchandise exports) of El Salvador per year?
Give a very brief answer. 1.04. What is the average Imports(as % of merchandise exports) in Hong Kong per year?
Offer a terse response. 1.96. What is the average Imports(as % of merchandise exports) in Paraguay per year?
Keep it short and to the point. 0.98. What is the average Imports(as % of merchandise exports) of Swaziland per year?
Keep it short and to the point. 0.94. In the year 2001, what is the difference between the Imports(as % of merchandise exports) of El Salvador and Imports(as % of merchandise exports) of Hong Kong?
Keep it short and to the point. -0.89. In the year 2001, what is the difference between the Imports(as % of merchandise exports) in El Salvador and Imports(as % of merchandise exports) in Paraguay?
Provide a succinct answer. -0.17. In the year 2001, what is the difference between the Imports(as % of merchandise exports) in El Salvador and Imports(as % of merchandise exports) in Swaziland?
Offer a very short reply. -0.42. In the year 2001, what is the difference between the Imports(as % of merchandise exports) of Hong Kong and Imports(as % of merchandise exports) of Paraguay?
Offer a terse response. 0.72. In the year 2001, what is the difference between the Imports(as % of merchandise exports) of Hong Kong and Imports(as % of merchandise exports) of Swaziland?
Offer a very short reply. 0.47. In the year 2001, what is the difference between the Imports(as % of merchandise exports) of Paraguay and Imports(as % of merchandise exports) of Swaziland?
Offer a very short reply. -0.25. In the year 2002, what is the difference between the Imports(as % of merchandise exports) of El Salvador and Imports(as % of merchandise exports) of Hong Kong?
Make the answer very short. -0.88. In the year 2002, what is the difference between the Imports(as % of merchandise exports) of El Salvador and Imports(as % of merchandise exports) of Paraguay?
Your response must be concise. -0.37. In the year 2002, what is the difference between the Imports(as % of merchandise exports) in El Salvador and Imports(as % of merchandise exports) in Swaziland?
Give a very brief answer. -0.08. In the year 2002, what is the difference between the Imports(as % of merchandise exports) in Hong Kong and Imports(as % of merchandise exports) in Paraguay?
Provide a short and direct response. 0.51. In the year 2002, what is the difference between the Imports(as % of merchandise exports) of Hong Kong and Imports(as % of merchandise exports) of Swaziland?
Keep it short and to the point. 0.8. In the year 2002, what is the difference between the Imports(as % of merchandise exports) of Paraguay and Imports(as % of merchandise exports) of Swaziland?
Keep it short and to the point. 0.29. In the year 2003, what is the difference between the Imports(as % of merchandise exports) of El Salvador and Imports(as % of merchandise exports) of Hong Kong?
Offer a very short reply. -0.88. In the year 2003, what is the difference between the Imports(as % of merchandise exports) of El Salvador and Imports(as % of merchandise exports) of Paraguay?
Give a very brief answer. -0.27. In the year 2003, what is the difference between the Imports(as % of merchandise exports) of El Salvador and Imports(as % of merchandise exports) of Swaziland?
Offer a terse response. 0.05. In the year 2003, what is the difference between the Imports(as % of merchandise exports) of Hong Kong and Imports(as % of merchandise exports) of Paraguay?
Your answer should be very brief. 0.6. In the year 2003, what is the difference between the Imports(as % of merchandise exports) of Hong Kong and Imports(as % of merchandise exports) of Swaziland?
Keep it short and to the point. 0.92. In the year 2003, what is the difference between the Imports(as % of merchandise exports) of Paraguay and Imports(as % of merchandise exports) of Swaziland?
Provide a succinct answer. 0.32. In the year 2004, what is the difference between the Imports(as % of merchandise exports) of El Salvador and Imports(as % of merchandise exports) of Hong Kong?
Make the answer very short. -1.02. In the year 2004, what is the difference between the Imports(as % of merchandise exports) in El Salvador and Imports(as % of merchandise exports) in Paraguay?
Your answer should be compact. -0.11. In the year 2004, what is the difference between the Imports(as % of merchandise exports) in El Salvador and Imports(as % of merchandise exports) in Swaziland?
Provide a succinct answer. 0.17. In the year 2004, what is the difference between the Imports(as % of merchandise exports) in Hong Kong and Imports(as % of merchandise exports) in Paraguay?
Provide a succinct answer. 0.91. In the year 2004, what is the difference between the Imports(as % of merchandise exports) in Hong Kong and Imports(as % of merchandise exports) in Swaziland?
Your answer should be very brief. 1.19. In the year 2004, what is the difference between the Imports(as % of merchandise exports) of Paraguay and Imports(as % of merchandise exports) of Swaziland?
Your answer should be compact. 0.28. In the year 2005, what is the difference between the Imports(as % of merchandise exports) in El Salvador and Imports(as % of merchandise exports) in Hong Kong?
Provide a succinct answer. -0.46. In the year 2005, what is the difference between the Imports(as % of merchandise exports) in El Salvador and Imports(as % of merchandise exports) in Paraguay?
Make the answer very short. 0.27. In the year 2005, what is the difference between the Imports(as % of merchandise exports) in El Salvador and Imports(as % of merchandise exports) in Swaziland?
Your response must be concise. 0.66. In the year 2005, what is the difference between the Imports(as % of merchandise exports) in Hong Kong and Imports(as % of merchandise exports) in Paraguay?
Your response must be concise. 0.72. In the year 2005, what is the difference between the Imports(as % of merchandise exports) of Hong Kong and Imports(as % of merchandise exports) of Swaziland?
Provide a succinct answer. 1.12. In the year 2005, what is the difference between the Imports(as % of merchandise exports) of Paraguay and Imports(as % of merchandise exports) of Swaziland?
Keep it short and to the point. 0.39. In the year 2006, what is the difference between the Imports(as % of merchandise exports) in El Salvador and Imports(as % of merchandise exports) in Hong Kong?
Make the answer very short. -1.2. In the year 2006, what is the difference between the Imports(as % of merchandise exports) in El Salvador and Imports(as % of merchandise exports) in Paraguay?
Offer a terse response. 0.4. In the year 2006, what is the difference between the Imports(as % of merchandise exports) in El Salvador and Imports(as % of merchandise exports) in Swaziland?
Ensure brevity in your answer.  0.1. In the year 2006, what is the difference between the Imports(as % of merchandise exports) in Hong Kong and Imports(as % of merchandise exports) in Paraguay?
Offer a very short reply. 1.6. In the year 2006, what is the difference between the Imports(as % of merchandise exports) of Hong Kong and Imports(as % of merchandise exports) of Swaziland?
Give a very brief answer. 1.3. In the year 2006, what is the difference between the Imports(as % of merchandise exports) of Paraguay and Imports(as % of merchandise exports) of Swaziland?
Provide a short and direct response. -0.3. In the year 2007, what is the difference between the Imports(as % of merchandise exports) in El Salvador and Imports(as % of merchandise exports) in Hong Kong?
Provide a short and direct response. -1.1. In the year 2007, what is the difference between the Imports(as % of merchandise exports) of El Salvador and Imports(as % of merchandise exports) of Paraguay?
Ensure brevity in your answer.  0.68. In the year 2007, what is the difference between the Imports(as % of merchandise exports) of El Salvador and Imports(as % of merchandise exports) of Swaziland?
Provide a succinct answer. 0.2. In the year 2007, what is the difference between the Imports(as % of merchandise exports) in Hong Kong and Imports(as % of merchandise exports) in Paraguay?
Provide a short and direct response. 1.78. In the year 2007, what is the difference between the Imports(as % of merchandise exports) of Hong Kong and Imports(as % of merchandise exports) of Swaziland?
Ensure brevity in your answer.  1.3. In the year 2007, what is the difference between the Imports(as % of merchandise exports) of Paraguay and Imports(as % of merchandise exports) of Swaziland?
Offer a very short reply. -0.48. What is the ratio of the Imports(as % of merchandise exports) of El Salvador in 2001 to that in 2002?
Give a very brief answer. 0.98. What is the ratio of the Imports(as % of merchandise exports) in Paraguay in 2001 to that in 2002?
Provide a succinct answer. 0.82. What is the ratio of the Imports(as % of merchandise exports) in Swaziland in 2001 to that in 2002?
Make the answer very short. 1.37. What is the ratio of the Imports(as % of merchandise exports) of El Salvador in 2001 to that in 2003?
Offer a very short reply. 0.93. What is the ratio of the Imports(as % of merchandise exports) in Hong Kong in 2001 to that in 2003?
Ensure brevity in your answer.  0.97. What is the ratio of the Imports(as % of merchandise exports) in Paraguay in 2001 to that in 2003?
Keep it short and to the point. 0.85. What is the ratio of the Imports(as % of merchandise exports) in Swaziland in 2001 to that in 2003?
Provide a succinct answer. 1.49. What is the ratio of the Imports(as % of merchandise exports) of El Salvador in 2001 to that in 2004?
Keep it short and to the point. 0.99. What is the ratio of the Imports(as % of merchandise exports) in Hong Kong in 2001 to that in 2004?
Provide a short and direct response. 0.92. What is the ratio of the Imports(as % of merchandise exports) in Paraguay in 2001 to that in 2004?
Give a very brief answer. 1.05. What is the ratio of the Imports(as % of merchandise exports) of Swaziland in 2001 to that in 2004?
Give a very brief answer. 1.9. What is the ratio of the Imports(as % of merchandise exports) in El Salvador in 2001 to that in 2005?
Give a very brief answer. 0.61. What is the ratio of the Imports(as % of merchandise exports) of Paraguay in 2001 to that in 2005?
Your response must be concise. 0.93. What is the ratio of the Imports(as % of merchandise exports) in Swaziland in 2001 to that in 2005?
Make the answer very short. 1.88. What is the ratio of the Imports(as % of merchandise exports) in El Salvador in 2001 to that in 2006?
Your response must be concise. 0.62. What is the ratio of the Imports(as % of merchandise exports) of Hong Kong in 2001 to that in 2006?
Your response must be concise. 0.68. What is the ratio of the Imports(as % of merchandise exports) in Paraguay in 2001 to that in 2006?
Keep it short and to the point. 1.08. What is the ratio of the Imports(as % of merchandise exports) in Swaziland in 2001 to that in 2006?
Keep it short and to the point. 1.02. What is the ratio of the Imports(as % of merchandise exports) in El Salvador in 2001 to that in 2007?
Give a very brief answer. 0.58. What is the ratio of the Imports(as % of merchandise exports) in Hong Kong in 2001 to that in 2007?
Provide a short and direct response. 0.68. What is the ratio of the Imports(as % of merchandise exports) of Paraguay in 2001 to that in 2007?
Provide a short and direct response. 1.38. What is the ratio of the Imports(as % of merchandise exports) of Swaziland in 2001 to that in 2007?
Keep it short and to the point. 1.04. What is the ratio of the Imports(as % of merchandise exports) in El Salvador in 2002 to that in 2003?
Keep it short and to the point. 0.94. What is the ratio of the Imports(as % of merchandise exports) in Hong Kong in 2002 to that in 2003?
Ensure brevity in your answer.  0.97. What is the ratio of the Imports(as % of merchandise exports) in Paraguay in 2002 to that in 2003?
Offer a terse response. 1.04. What is the ratio of the Imports(as % of merchandise exports) of Swaziland in 2002 to that in 2003?
Ensure brevity in your answer.  1.09. What is the ratio of the Imports(as % of merchandise exports) of Hong Kong in 2002 to that in 2004?
Your response must be concise. 0.92. What is the ratio of the Imports(as % of merchandise exports) of Paraguay in 2002 to that in 2004?
Offer a very short reply. 1.28. What is the ratio of the Imports(as % of merchandise exports) of Swaziland in 2002 to that in 2004?
Keep it short and to the point. 1.39. What is the ratio of the Imports(as % of merchandise exports) in El Salvador in 2002 to that in 2005?
Keep it short and to the point. 0.63. What is the ratio of the Imports(as % of merchandise exports) of Hong Kong in 2002 to that in 2005?
Offer a very short reply. 0.96. What is the ratio of the Imports(as % of merchandise exports) of Paraguay in 2002 to that in 2005?
Keep it short and to the point. 1.14. What is the ratio of the Imports(as % of merchandise exports) in Swaziland in 2002 to that in 2005?
Ensure brevity in your answer.  1.38. What is the ratio of the Imports(as % of merchandise exports) in El Salvador in 2002 to that in 2006?
Offer a very short reply. 0.63. What is the ratio of the Imports(as % of merchandise exports) in Hong Kong in 2002 to that in 2006?
Offer a very short reply. 0.68. What is the ratio of the Imports(as % of merchandise exports) of Paraguay in 2002 to that in 2006?
Give a very brief answer. 1.32. What is the ratio of the Imports(as % of merchandise exports) of Swaziland in 2002 to that in 2006?
Your answer should be very brief. 0.74. What is the ratio of the Imports(as % of merchandise exports) of El Salvador in 2002 to that in 2007?
Your answer should be compact. 0.59. What is the ratio of the Imports(as % of merchandise exports) of Hong Kong in 2002 to that in 2007?
Provide a succinct answer. 0.68. What is the ratio of the Imports(as % of merchandise exports) of Paraguay in 2002 to that in 2007?
Offer a terse response. 1.69. What is the ratio of the Imports(as % of merchandise exports) in Swaziland in 2002 to that in 2007?
Offer a very short reply. 0.76. What is the ratio of the Imports(as % of merchandise exports) in El Salvador in 2003 to that in 2004?
Keep it short and to the point. 1.07. What is the ratio of the Imports(as % of merchandise exports) of Hong Kong in 2003 to that in 2004?
Your answer should be compact. 0.95. What is the ratio of the Imports(as % of merchandise exports) in Paraguay in 2003 to that in 2004?
Ensure brevity in your answer.  1.23. What is the ratio of the Imports(as % of merchandise exports) in Swaziland in 2003 to that in 2004?
Your response must be concise. 1.27. What is the ratio of the Imports(as % of merchandise exports) of El Salvador in 2003 to that in 2005?
Offer a terse response. 0.66. What is the ratio of the Imports(as % of merchandise exports) in Hong Kong in 2003 to that in 2005?
Keep it short and to the point. 0.99. What is the ratio of the Imports(as % of merchandise exports) of Paraguay in 2003 to that in 2005?
Make the answer very short. 1.1. What is the ratio of the Imports(as % of merchandise exports) of Swaziland in 2003 to that in 2005?
Provide a short and direct response. 1.26. What is the ratio of the Imports(as % of merchandise exports) of El Salvador in 2003 to that in 2006?
Provide a succinct answer. 0.67. What is the ratio of the Imports(as % of merchandise exports) of Hong Kong in 2003 to that in 2006?
Provide a short and direct response. 0.7. What is the ratio of the Imports(as % of merchandise exports) in Paraguay in 2003 to that in 2006?
Your answer should be very brief. 1.27. What is the ratio of the Imports(as % of merchandise exports) of Swaziland in 2003 to that in 2006?
Offer a very short reply. 0.68. What is the ratio of the Imports(as % of merchandise exports) in El Salvador in 2003 to that in 2007?
Offer a terse response. 0.63. What is the ratio of the Imports(as % of merchandise exports) in Hong Kong in 2003 to that in 2007?
Provide a short and direct response. 0.7. What is the ratio of the Imports(as % of merchandise exports) in Paraguay in 2003 to that in 2007?
Make the answer very short. 1.62. What is the ratio of the Imports(as % of merchandise exports) of Swaziland in 2003 to that in 2007?
Offer a terse response. 0.7. What is the ratio of the Imports(as % of merchandise exports) of El Salvador in 2004 to that in 2005?
Give a very brief answer. 0.62. What is the ratio of the Imports(as % of merchandise exports) of Hong Kong in 2004 to that in 2005?
Make the answer very short. 1.04. What is the ratio of the Imports(as % of merchandise exports) in Paraguay in 2004 to that in 2005?
Your response must be concise. 0.89. What is the ratio of the Imports(as % of merchandise exports) of El Salvador in 2004 to that in 2006?
Provide a succinct answer. 0.63. What is the ratio of the Imports(as % of merchandise exports) in Hong Kong in 2004 to that in 2006?
Offer a terse response. 0.73. What is the ratio of the Imports(as % of merchandise exports) of Paraguay in 2004 to that in 2006?
Provide a short and direct response. 1.03. What is the ratio of the Imports(as % of merchandise exports) of Swaziland in 2004 to that in 2006?
Provide a succinct answer. 0.54. What is the ratio of the Imports(as % of merchandise exports) in El Salvador in 2004 to that in 2007?
Ensure brevity in your answer.  0.59. What is the ratio of the Imports(as % of merchandise exports) in Hong Kong in 2004 to that in 2007?
Keep it short and to the point. 0.74. What is the ratio of the Imports(as % of merchandise exports) in Paraguay in 2004 to that in 2007?
Ensure brevity in your answer.  1.32. What is the ratio of the Imports(as % of merchandise exports) of Swaziland in 2004 to that in 2007?
Provide a succinct answer. 0.55. What is the ratio of the Imports(as % of merchandise exports) of El Salvador in 2005 to that in 2006?
Make the answer very short. 1.01. What is the ratio of the Imports(as % of merchandise exports) in Hong Kong in 2005 to that in 2006?
Give a very brief answer. 0.7. What is the ratio of the Imports(as % of merchandise exports) of Paraguay in 2005 to that in 2006?
Keep it short and to the point. 1.16. What is the ratio of the Imports(as % of merchandise exports) of Swaziland in 2005 to that in 2006?
Keep it short and to the point. 0.54. What is the ratio of the Imports(as % of merchandise exports) in El Salvador in 2005 to that in 2007?
Your answer should be very brief. 0.95. What is the ratio of the Imports(as % of merchandise exports) in Hong Kong in 2005 to that in 2007?
Offer a very short reply. 0.71. What is the ratio of the Imports(as % of merchandise exports) of Paraguay in 2005 to that in 2007?
Make the answer very short. 1.48. What is the ratio of the Imports(as % of merchandise exports) of Swaziland in 2005 to that in 2007?
Give a very brief answer. 0.55. What is the ratio of the Imports(as % of merchandise exports) of El Salvador in 2006 to that in 2007?
Make the answer very short. 0.94. What is the ratio of the Imports(as % of merchandise exports) of Hong Kong in 2006 to that in 2007?
Your response must be concise. 1.01. What is the ratio of the Imports(as % of merchandise exports) in Paraguay in 2006 to that in 2007?
Ensure brevity in your answer.  1.28. What is the difference between the highest and the second highest Imports(as % of merchandise exports) in El Salvador?
Provide a short and direct response. 0.07. What is the difference between the highest and the second highest Imports(as % of merchandise exports) of Hong Kong?
Your answer should be very brief. 0.02. What is the difference between the highest and the second highest Imports(as % of merchandise exports) in Paraguay?
Offer a very short reply. 0.05. What is the difference between the highest and the second highest Imports(as % of merchandise exports) of Swaziland?
Ensure brevity in your answer.  0.02. What is the difference between the highest and the lowest Imports(as % of merchandise exports) of El Salvador?
Give a very brief answer. 0.58. What is the difference between the highest and the lowest Imports(as % of merchandise exports) of Hong Kong?
Your response must be concise. 0.81. What is the difference between the highest and the lowest Imports(as % of merchandise exports) in Paraguay?
Ensure brevity in your answer.  0.48. What is the difference between the highest and the lowest Imports(as % of merchandise exports) in Swaziland?
Make the answer very short. 0.58. 